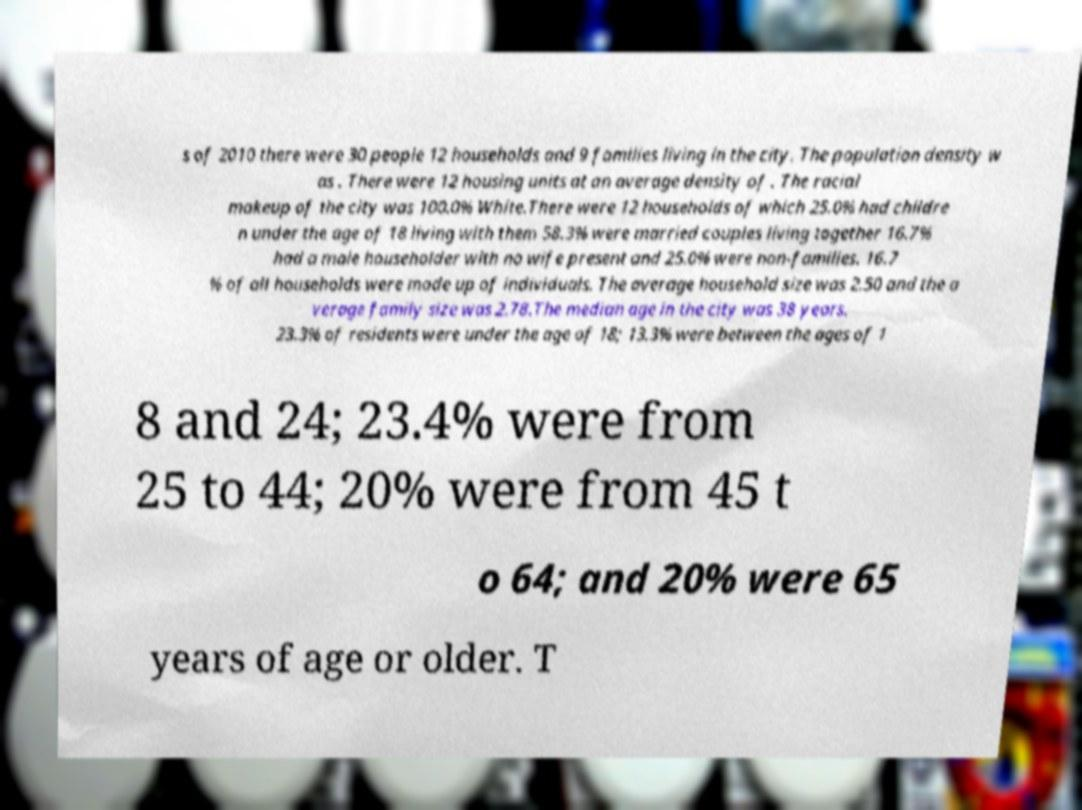Can you read and provide the text displayed in the image?This photo seems to have some interesting text. Can you extract and type it out for me? s of 2010 there were 30 people 12 households and 9 families living in the city. The population density w as . There were 12 housing units at an average density of . The racial makeup of the city was 100.0% White.There were 12 households of which 25.0% had childre n under the age of 18 living with them 58.3% were married couples living together 16.7% had a male householder with no wife present and 25.0% were non-families. 16.7 % of all households were made up of individuals. The average household size was 2.50 and the a verage family size was 2.78.The median age in the city was 38 years. 23.3% of residents were under the age of 18; 13.3% were between the ages of 1 8 and 24; 23.4% were from 25 to 44; 20% were from 45 t o 64; and 20% were 65 years of age or older. T 